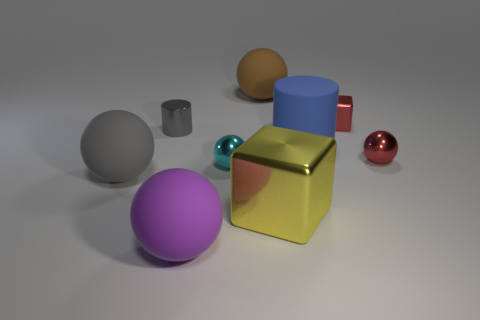Subtract 1 blocks. How many blocks are left? 1 Add 1 red spheres. How many objects exist? 10 Subtract all red metal balls. How many balls are left? 4 Subtract 0 purple cylinders. How many objects are left? 9 Subtract all balls. How many objects are left? 4 Subtract all purple spheres. Subtract all brown cylinders. How many spheres are left? 4 Subtract all yellow cylinders. How many brown spheres are left? 1 Subtract all large purple matte spheres. Subtract all tiny blue balls. How many objects are left? 8 Add 7 brown matte balls. How many brown matte balls are left? 8 Add 8 small cylinders. How many small cylinders exist? 9 